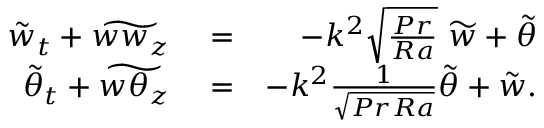<formula> <loc_0><loc_0><loc_500><loc_500>\begin{array} { r l r } { \tilde { w } _ { t } + \widetilde { w w _ { z } } } & = } & { - k ^ { 2 } \sqrt { \frac { P r } { R a } } \ \widetilde { w } + \tilde { \theta } } \\ { \tilde { \theta } _ { t } + \widetilde { w \theta _ { z } } } & = } & { - k ^ { 2 } \frac { 1 } { \sqrt { P r R a } } \widetilde { \theta } + \tilde { w } . } \end{array}</formula> 